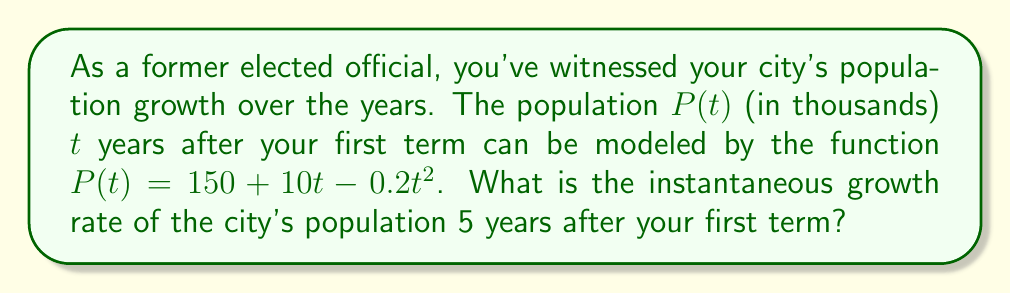Can you solve this math problem? To find the instantaneous growth rate, we need to calculate the derivative of the population function and evaluate it at $t = 5$.

1. Given population function: $P(t) = 150 + 10t - 0.2t^2$

2. Calculate the derivative $P'(t)$:
   $$\frac{d}{dt}[150] = 0$$
   $$\frac{d}{dt}[10t] = 10$$
   $$\frac{d}{dt}[-0.2t^2] = -0.4t$$

   Combining these terms: $P'(t) = 10 - 0.4t$

3. Evaluate $P'(t)$ at $t = 5$:
   $$P'(5) = 10 - 0.4(5) = 10 - 2 = 8$$

The instantaneous growth rate is 8 thousand people per year, 5 years after your first term.
Answer: 8 thousand people per year 